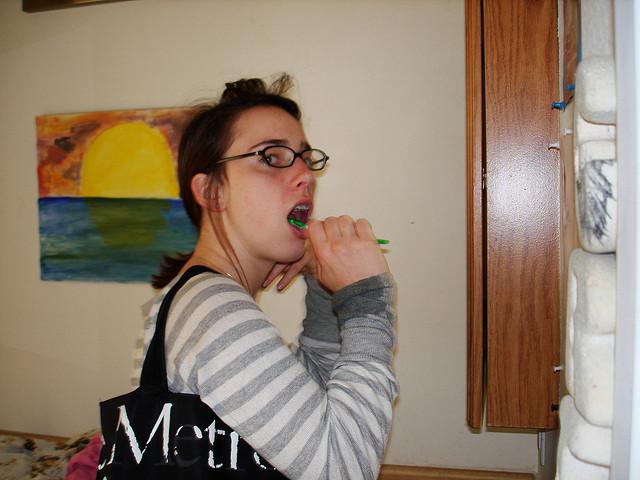Is the woman wearing earrings?
Give a very brief answer. No. Does the girl have a colored bag?
Give a very brief answer. No. Is the woman eating a donut?
Keep it brief. No. Is the woman's hair tied back?
Give a very brief answer. Yes. How many people are here?
Concise answer only. 1. What COLOR IS THE GIRL'S SWEATER?
Concise answer only. Gray and white. Are they in the bathroom?
Answer briefly. No. Could the person be texting?
Be succinct. No. What is the woman doing?
Write a very short answer. Brushing teeth. What is the girl doing?
Write a very short answer. Brushing teeth. Is the woman lounging?
Be succinct. No. Is that a sun in the painting?
Quick response, please. Yes. 